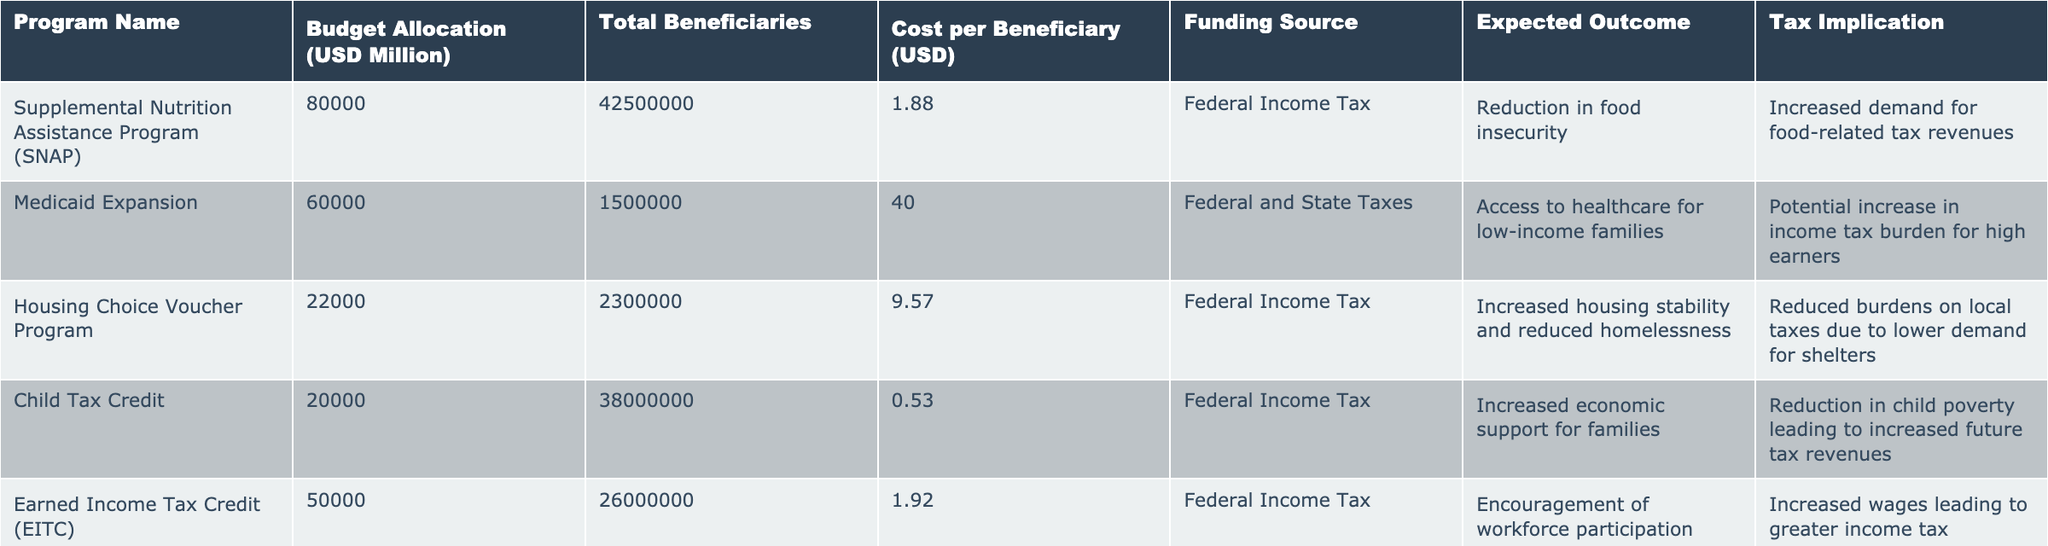What is the total budget allocation for the Medicaid Expansion program? The table shows that the budget allocation for the Medicaid Expansion program is listed directly as 60,000 million USD.
Answer: 60,000 million USD What is the cost per beneficiary for the Child Tax Credit program? The cost per beneficiary for the Child Tax Credit program is provided in the table as 0.53 USD.
Answer: 0.53 USD How many total beneficiaries are there for the Housing Choice Voucher Program? The column for total beneficiaries indicates that there are 2,300,000 beneficiaries for the Housing Choice Voucher Program.
Answer: 2,300,000 What is the expected outcome for the Earned Income Tax Credit program? The expected outcome for the Earned Income Tax Credit program is to encourage workforce participation.
Answer: Encourage workforce participation What is the combined budget allocation for all programs funded through Federal Income Tax? The budget allocation for programs under Federal Income Tax are SNAP (80,000 million), Housing Choice Voucher (22,000 million), Child Tax Credit (20,000 million), and EITC (50,000 million). Adding these up gives a total of 172,000 million USD.
Answer: 172,000 million USD Is there an expected outcome of reduced burdens on local taxes for the Supplemental Nutrition Assistance Program? The expected outcome listed for the Supplemental Nutrition Assistance Program is a reduction in food insecurity, not specifically about local taxes. Therefore, the answer is no.
Answer: No Which program has the highest cost per beneficiary, and what is that cost? By examining the cost per beneficiary for each program, the Medicaid Expansion program has the highest cost per beneficiary at 40 USD.
Answer: Medicaid Expansion, 40 USD What is the total number of beneficiaries for all programs listed in the table? The total number of beneficiaries can be found by summing all beneficiaries from each program: (42,500,000 + 1,500,000 + 2,300,000 + 38,000,000 + 26,000,000 + 500,000 + 9,000,000) = 119,800,000.
Answer: 119,800,000 If the goal of the SSDI program is to support disabled individuals, what is the corresponding tax implication associated with it? The tax implication for the Social Security Disability Insurance program is a potential increase in payroll tax rates to maintain fund solvency.
Answer: Increase in payroll tax rates How does the expected outcome of the Job Training Programs relate to tax implications? The expected outcome of Job Training Programs is increased employment rates, which leads to increased income tax collection from job placements, connecting the two aspects. This requires considering both the outcomes and implications.
Answer: Increased employment leads to increased income tax collection 